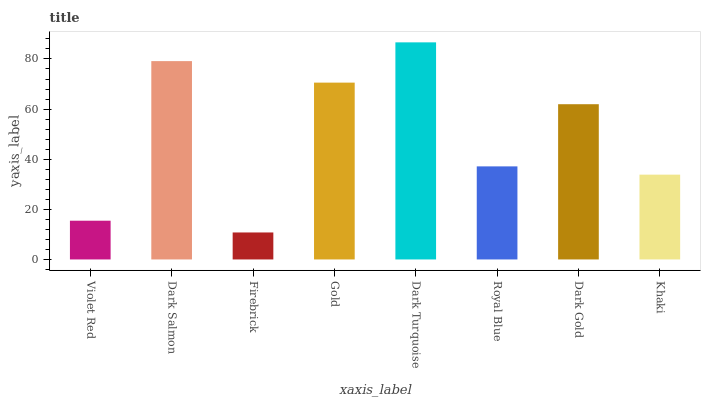Is Firebrick the minimum?
Answer yes or no. Yes. Is Dark Turquoise the maximum?
Answer yes or no. Yes. Is Dark Salmon the minimum?
Answer yes or no. No. Is Dark Salmon the maximum?
Answer yes or no. No. Is Dark Salmon greater than Violet Red?
Answer yes or no. Yes. Is Violet Red less than Dark Salmon?
Answer yes or no. Yes. Is Violet Red greater than Dark Salmon?
Answer yes or no. No. Is Dark Salmon less than Violet Red?
Answer yes or no. No. Is Dark Gold the high median?
Answer yes or no. Yes. Is Royal Blue the low median?
Answer yes or no. Yes. Is Dark Turquoise the high median?
Answer yes or no. No. Is Dark Salmon the low median?
Answer yes or no. No. 